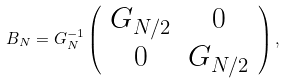Convert formula to latex. <formula><loc_0><loc_0><loc_500><loc_500>B _ { N } = G _ { N } ^ { - 1 } \left ( \begin{array} { c c } G _ { N / 2 } & 0 \\ 0 & G _ { N / 2 } \\ \end{array} \right ) ,</formula> 